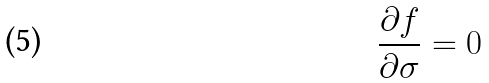<formula> <loc_0><loc_0><loc_500><loc_500>\frac { \partial f } { \partial \sigma } = 0</formula> 